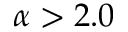Convert formula to latex. <formula><loc_0><loc_0><loc_500><loc_500>\alpha > 2 . 0</formula> 